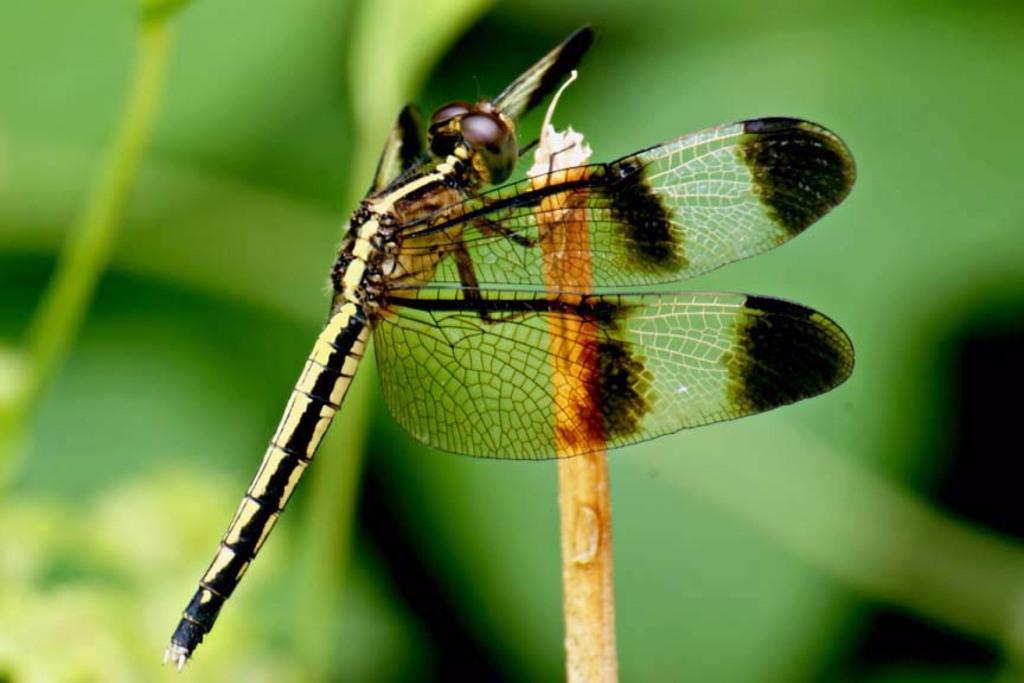What is the main subject of the image? There is a butterfly in the image. Where is the butterfly located? The butterfly is on a stem. What color is the background of the image? The background of the image is green. What type of bread is being served at the party in the image? There is no party or bread present in the image; it features a butterfly on a stem with a green background. 